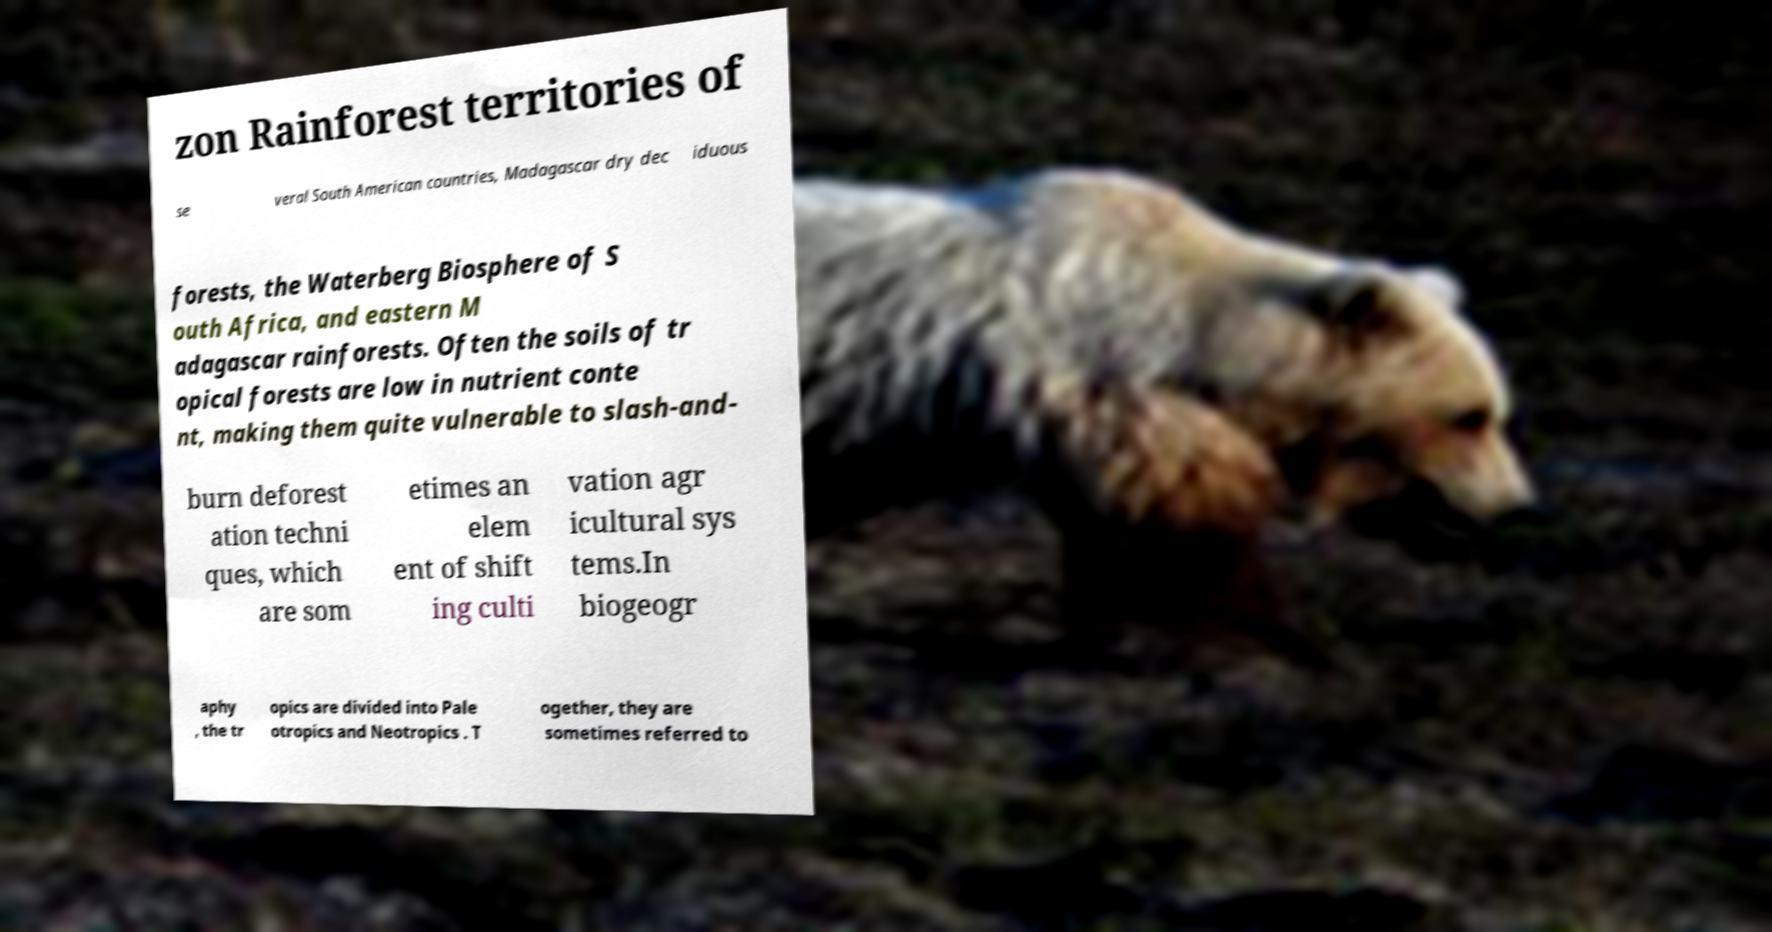Please identify and transcribe the text found in this image. zon Rainforest territories of se veral South American countries, Madagascar dry dec iduous forests, the Waterberg Biosphere of S outh Africa, and eastern M adagascar rainforests. Often the soils of tr opical forests are low in nutrient conte nt, making them quite vulnerable to slash-and- burn deforest ation techni ques, which are som etimes an elem ent of shift ing culti vation agr icultural sys tems.In biogeogr aphy , the tr opics are divided into Pale otropics and Neotropics . T ogether, they are sometimes referred to 